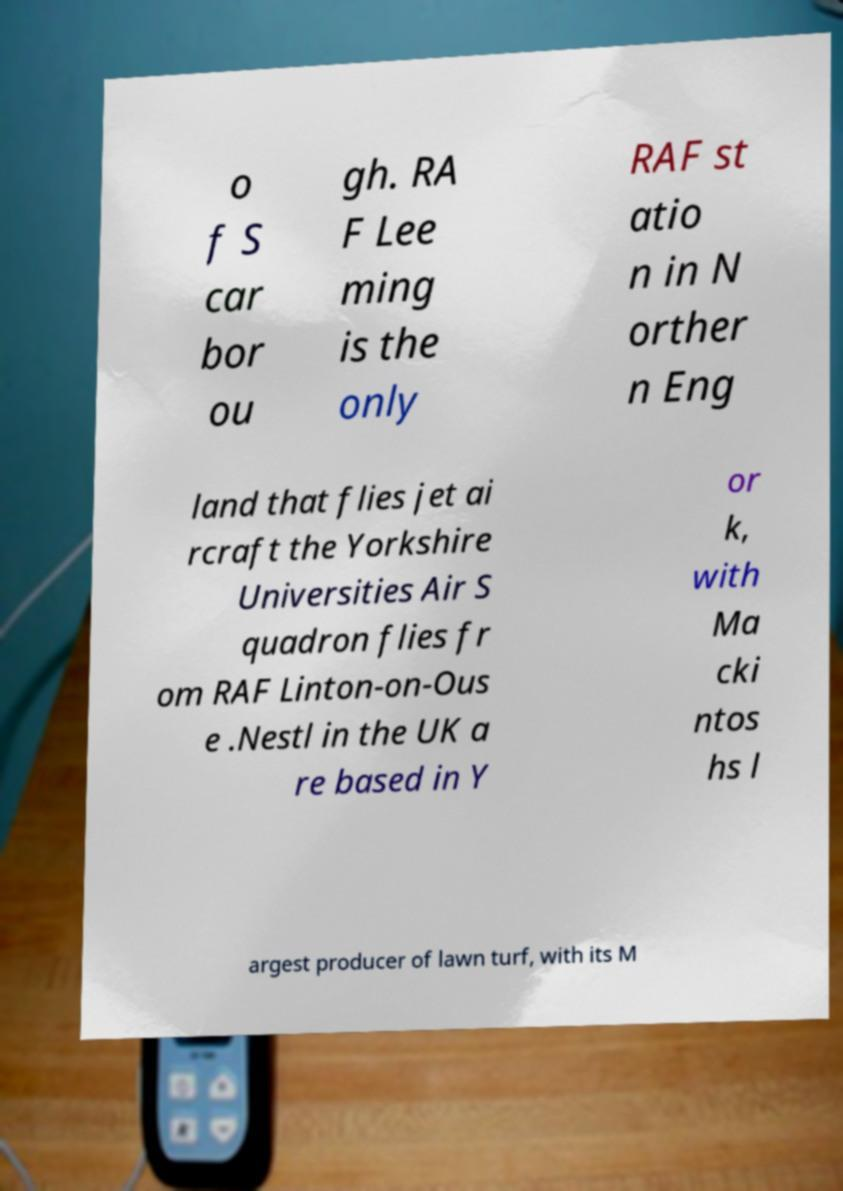Please read and relay the text visible in this image. What does it say? o f S car bor ou gh. RA F Lee ming is the only RAF st atio n in N orther n Eng land that flies jet ai rcraft the Yorkshire Universities Air S quadron flies fr om RAF Linton-on-Ous e .Nestl in the UK a re based in Y or k, with Ma cki ntos hs l argest producer of lawn turf, with its M 